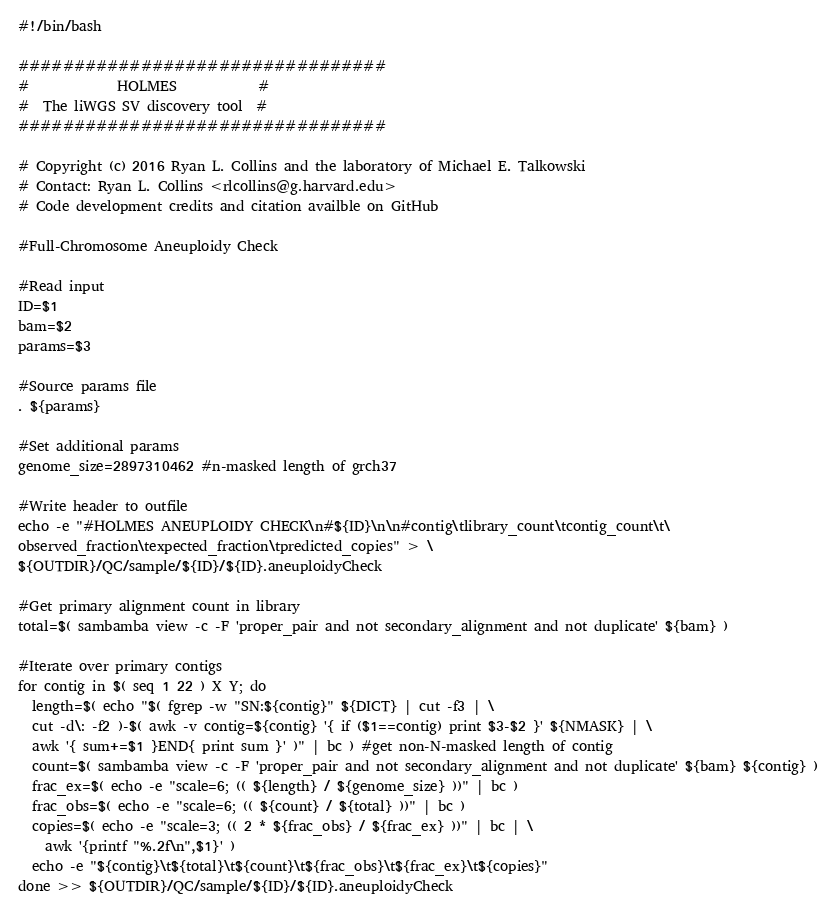Convert code to text. <code><loc_0><loc_0><loc_500><loc_500><_Bash_>#!/bin/bash

#################################
#             HOLMES            #
#  The liWGS SV discovery tool  #
#################################

# Copyright (c) 2016 Ryan L. Collins and the laboratory of Michael E. Talkowski
# Contact: Ryan L. Collins <rlcollins@g.harvard.edu>
# Code development credits and citation availble on GitHub

#Full-Chromosome Aneuploidy Check

#Read input
ID=$1
bam=$2
params=$3

#Source params file
. ${params}

#Set additional params
genome_size=2897310462 #n-masked length of grch37

#Write header to outfile
echo -e "#HOLMES ANEUPLOIDY CHECK\n#${ID}\n\n#contig\tlibrary_count\tcontig_count\t\
observed_fraction\texpected_fraction\tpredicted_copies" > \
${OUTDIR}/QC/sample/${ID}/${ID}.aneuploidyCheck

#Get primary alignment count in library
total=$( sambamba view -c -F 'proper_pair and not secondary_alignment and not duplicate' ${bam} )

#Iterate over primary contigs
for contig in $( seq 1 22 ) X Y; do
  length=$( echo "$( fgrep -w "SN:${contig}" ${DICT} | cut -f3 | \
  cut -d\: -f2 )-$( awk -v contig=${contig} '{ if ($1==contig) print $3-$2 }' ${NMASK} | \
  awk '{ sum+=$1 }END{ print sum }' )" | bc ) #get non-N-masked length of contig
  count=$( sambamba view -c -F 'proper_pair and not secondary_alignment and not duplicate' ${bam} ${contig} )
  frac_ex=$( echo -e "scale=6; (( ${length} / ${genome_size} ))" | bc )
  frac_obs=$( echo -e "scale=6; (( ${count} / ${total} ))" | bc )
  copies=$( echo -e "scale=3; (( 2 * ${frac_obs} / ${frac_ex} ))" | bc | \
    awk '{printf "%.2f\n",$1}' )
  echo -e "${contig}\t${total}\t${count}\t${frac_obs}\t${frac_ex}\t${copies}"
done >> ${OUTDIR}/QC/sample/${ID}/${ID}.aneuploidyCheck</code> 